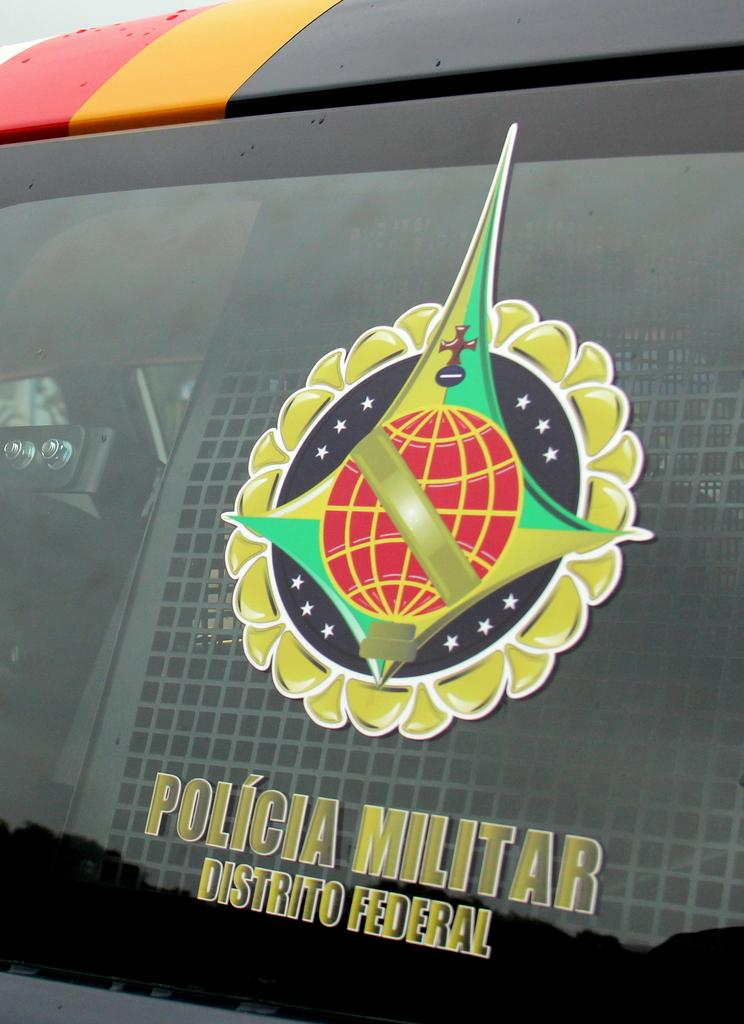<image>
Share a concise interpretation of the image provided. A logo that includes a red and yellow ball  says Polica Militar Distrito Federal under it. 